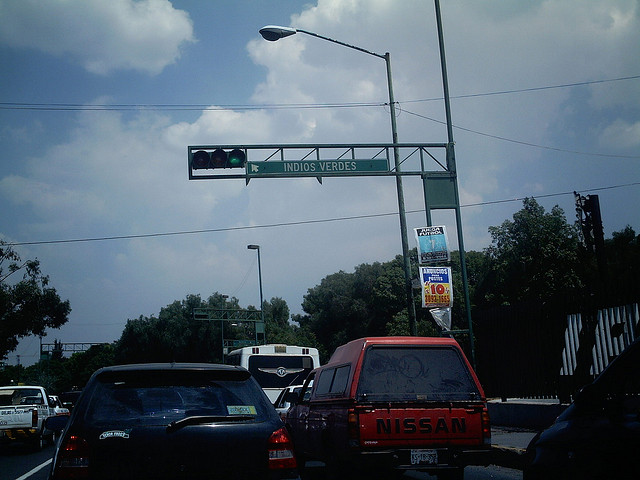How many trucks are there? There appears to be only one truck visible in the image. It's a red Nissan truck, and you can see it in the forefront, stopped at what looks like a traffic signal. 